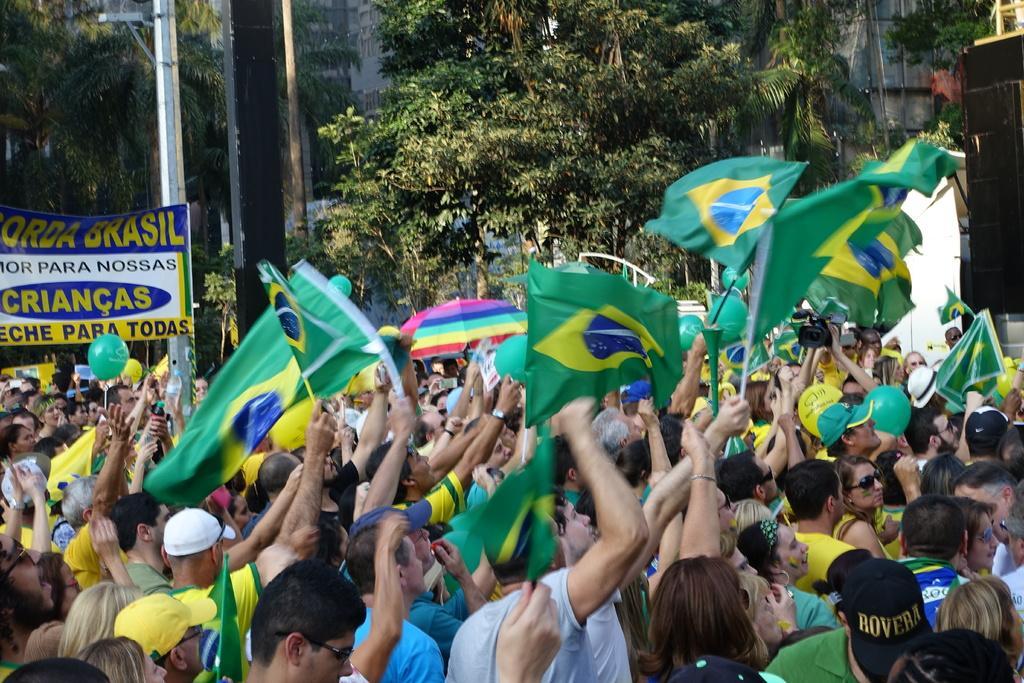Can you describe this image briefly? In this image I can see number of persons are standing and I can see few of them are holding flags which are green, blue and yellow in color. I can see a balloon, an umbrella, a banner and in the background I can see few trees and few buildings. 